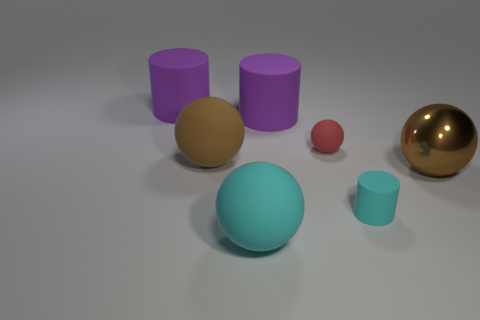Subtract all big cyan balls. How many balls are left? 3 Subtract 3 spheres. How many spheres are left? 1 Add 1 tiny cyan shiny things. How many objects exist? 8 Subtract all cylinders. How many objects are left? 4 Subtract all red balls. How many balls are left? 3 Subtract all purple cylinders. Subtract all cyan spheres. How many cylinders are left? 1 Subtract all blue spheres. How many purple cylinders are left? 2 Subtract all small cyan cylinders. Subtract all red spheres. How many objects are left? 5 Add 7 big cyan things. How many big cyan things are left? 8 Add 5 red rubber cylinders. How many red rubber cylinders exist? 5 